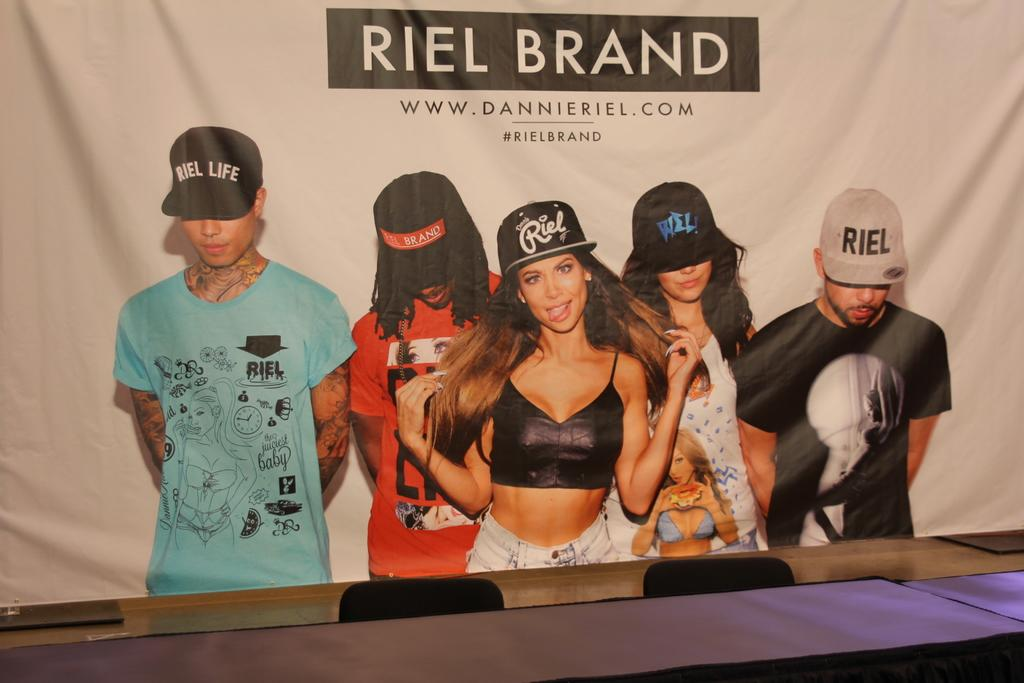What is the main object in the image? There is a banner in the image. What is depicted on the banner? The banner contains a group of people. How are the people in the group dressed? The people in the group are wearing different color dresses and caps. Is there any text on the banner? Yes, there is text written on the banner. What type of rake is the farmer using in the image? There is no farmer or rake present in the image. Is the quill used by any of the people in the group? There is no quill visible in the image. 